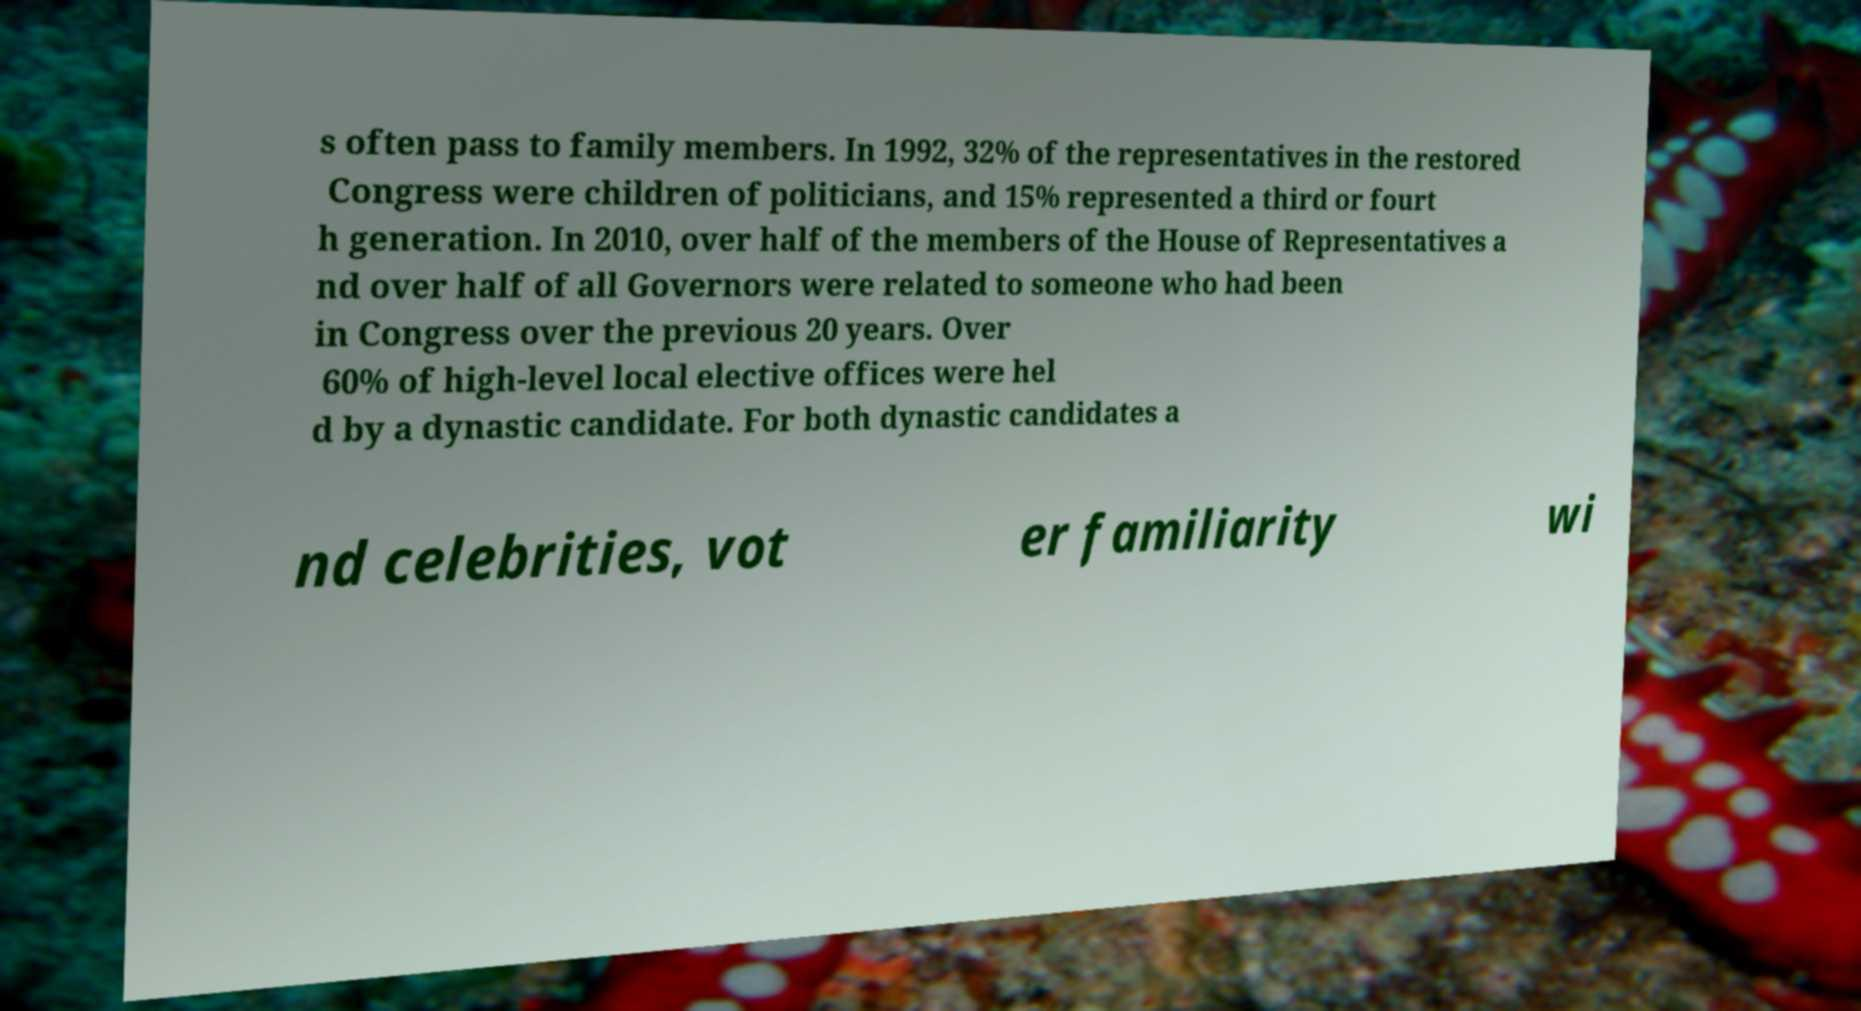Can you read and provide the text displayed in the image?This photo seems to have some interesting text. Can you extract and type it out for me? s often pass to family members. In 1992, 32% of the representatives in the restored Congress were children of politicians, and 15% represented a third or fourt h generation. In 2010, over half of the members of the House of Representatives a nd over half of all Governors were related to someone who had been in Congress over the previous 20 years. Over 60% of high-level local elective offices were hel d by a dynastic candidate. For both dynastic candidates a nd celebrities, vot er familiarity wi 